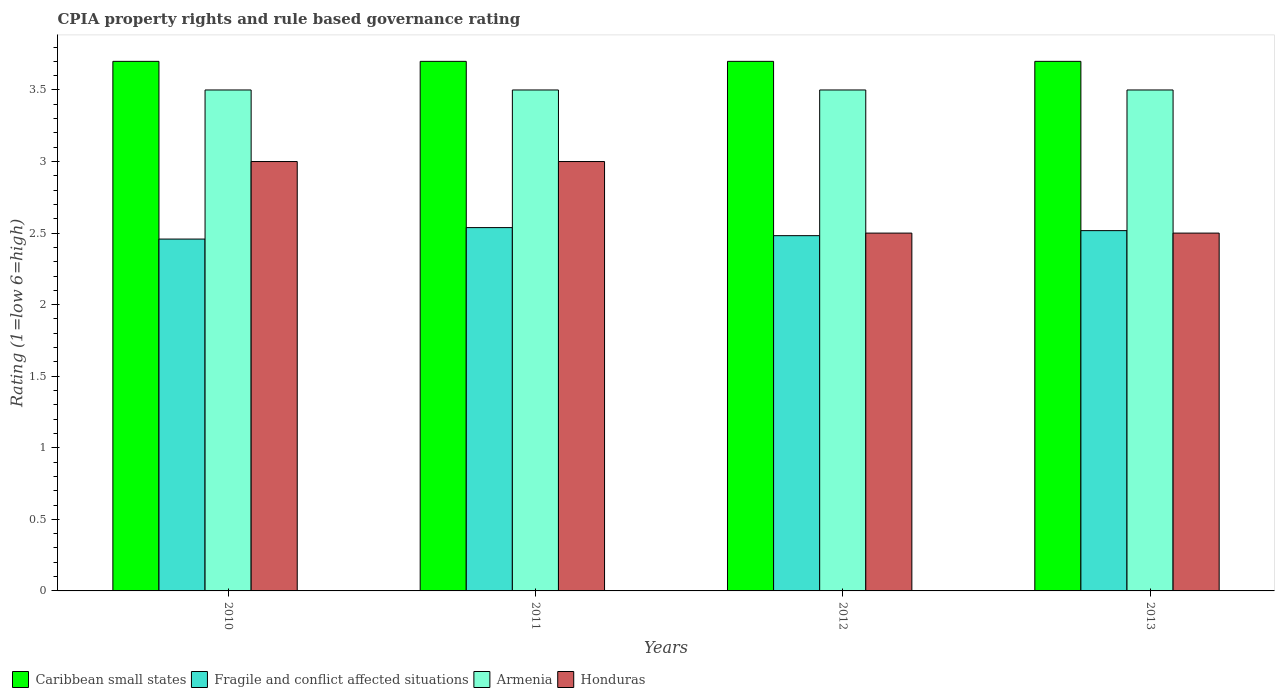How many different coloured bars are there?
Give a very brief answer. 4. How many groups of bars are there?
Provide a succinct answer. 4. Are the number of bars per tick equal to the number of legend labels?
Provide a succinct answer. Yes. Are the number of bars on each tick of the X-axis equal?
Provide a short and direct response. Yes. How many bars are there on the 2nd tick from the left?
Your answer should be compact. 4. What is the label of the 4th group of bars from the left?
Your answer should be very brief. 2013. What is the CPIA rating in Fragile and conflict affected situations in 2013?
Keep it short and to the point. 2.52. Across all years, what is the maximum CPIA rating in Caribbean small states?
Keep it short and to the point. 3.7. Across all years, what is the minimum CPIA rating in Fragile and conflict affected situations?
Make the answer very short. 2.46. What is the total CPIA rating in Fragile and conflict affected situations in the graph?
Offer a terse response. 10. What is the difference between the CPIA rating in Caribbean small states in 2010 and that in 2012?
Keep it short and to the point. 0. What is the difference between the CPIA rating in Fragile and conflict affected situations in 2011 and the CPIA rating in Honduras in 2013?
Your answer should be compact. 0.04. What is the average CPIA rating in Armenia per year?
Offer a terse response. 3.5. In the year 2011, what is the difference between the CPIA rating in Caribbean small states and CPIA rating in Armenia?
Ensure brevity in your answer.  0.2. In how many years, is the CPIA rating in Honduras greater than 3.3?
Offer a very short reply. 0. What is the ratio of the CPIA rating in Fragile and conflict affected situations in 2012 to that in 2013?
Your response must be concise. 0.99. Is the CPIA rating in Fragile and conflict affected situations in 2012 less than that in 2013?
Your response must be concise. Yes. Is the difference between the CPIA rating in Caribbean small states in 2011 and 2012 greater than the difference between the CPIA rating in Armenia in 2011 and 2012?
Your answer should be compact. No. What is the difference between the highest and the second highest CPIA rating in Caribbean small states?
Your answer should be very brief. 0. What is the difference between the highest and the lowest CPIA rating in Caribbean small states?
Keep it short and to the point. 0. Is the sum of the CPIA rating in Caribbean small states in 2011 and 2012 greater than the maximum CPIA rating in Armenia across all years?
Provide a short and direct response. Yes. What does the 3rd bar from the left in 2013 represents?
Give a very brief answer. Armenia. What does the 2nd bar from the right in 2012 represents?
Provide a short and direct response. Armenia. How many bars are there?
Provide a succinct answer. 16. Are all the bars in the graph horizontal?
Offer a very short reply. No. How many years are there in the graph?
Provide a succinct answer. 4. Are the values on the major ticks of Y-axis written in scientific E-notation?
Your answer should be very brief. No. Does the graph contain any zero values?
Provide a succinct answer. No. Does the graph contain grids?
Offer a terse response. No. How many legend labels are there?
Ensure brevity in your answer.  4. What is the title of the graph?
Give a very brief answer. CPIA property rights and rule based governance rating. Does "Tajikistan" appear as one of the legend labels in the graph?
Provide a succinct answer. No. What is the Rating (1=low 6=high) in Fragile and conflict affected situations in 2010?
Provide a succinct answer. 2.46. What is the Rating (1=low 6=high) of Armenia in 2010?
Your answer should be very brief. 3.5. What is the Rating (1=low 6=high) in Honduras in 2010?
Ensure brevity in your answer.  3. What is the Rating (1=low 6=high) in Fragile and conflict affected situations in 2011?
Your response must be concise. 2.54. What is the Rating (1=low 6=high) in Armenia in 2011?
Your answer should be very brief. 3.5. What is the Rating (1=low 6=high) in Honduras in 2011?
Keep it short and to the point. 3. What is the Rating (1=low 6=high) of Caribbean small states in 2012?
Make the answer very short. 3.7. What is the Rating (1=low 6=high) of Fragile and conflict affected situations in 2012?
Your response must be concise. 2.48. What is the Rating (1=low 6=high) in Caribbean small states in 2013?
Give a very brief answer. 3.7. What is the Rating (1=low 6=high) of Fragile and conflict affected situations in 2013?
Ensure brevity in your answer.  2.52. What is the Rating (1=low 6=high) in Armenia in 2013?
Offer a terse response. 3.5. What is the Rating (1=low 6=high) in Honduras in 2013?
Provide a succinct answer. 2.5. Across all years, what is the maximum Rating (1=low 6=high) of Fragile and conflict affected situations?
Offer a very short reply. 2.54. Across all years, what is the maximum Rating (1=low 6=high) of Honduras?
Your answer should be very brief. 3. Across all years, what is the minimum Rating (1=low 6=high) in Fragile and conflict affected situations?
Offer a very short reply. 2.46. What is the total Rating (1=low 6=high) of Fragile and conflict affected situations in the graph?
Your answer should be compact. 10. What is the total Rating (1=low 6=high) of Armenia in the graph?
Give a very brief answer. 14. What is the difference between the Rating (1=low 6=high) of Caribbean small states in 2010 and that in 2011?
Your response must be concise. 0. What is the difference between the Rating (1=low 6=high) of Fragile and conflict affected situations in 2010 and that in 2011?
Make the answer very short. -0.08. What is the difference between the Rating (1=low 6=high) in Caribbean small states in 2010 and that in 2012?
Your answer should be very brief. 0. What is the difference between the Rating (1=low 6=high) of Fragile and conflict affected situations in 2010 and that in 2012?
Your answer should be compact. -0.02. What is the difference between the Rating (1=low 6=high) of Honduras in 2010 and that in 2012?
Your answer should be very brief. 0.5. What is the difference between the Rating (1=low 6=high) in Fragile and conflict affected situations in 2010 and that in 2013?
Give a very brief answer. -0.06. What is the difference between the Rating (1=low 6=high) of Armenia in 2010 and that in 2013?
Provide a succinct answer. 0. What is the difference between the Rating (1=low 6=high) of Caribbean small states in 2011 and that in 2012?
Your response must be concise. 0. What is the difference between the Rating (1=low 6=high) of Fragile and conflict affected situations in 2011 and that in 2012?
Offer a very short reply. 0.06. What is the difference between the Rating (1=low 6=high) of Fragile and conflict affected situations in 2011 and that in 2013?
Your response must be concise. 0.02. What is the difference between the Rating (1=low 6=high) of Armenia in 2011 and that in 2013?
Make the answer very short. 0. What is the difference between the Rating (1=low 6=high) in Honduras in 2011 and that in 2013?
Make the answer very short. 0.5. What is the difference between the Rating (1=low 6=high) of Caribbean small states in 2012 and that in 2013?
Your answer should be very brief. 0. What is the difference between the Rating (1=low 6=high) in Fragile and conflict affected situations in 2012 and that in 2013?
Provide a short and direct response. -0.04. What is the difference between the Rating (1=low 6=high) in Caribbean small states in 2010 and the Rating (1=low 6=high) in Fragile and conflict affected situations in 2011?
Offer a terse response. 1.16. What is the difference between the Rating (1=low 6=high) in Fragile and conflict affected situations in 2010 and the Rating (1=low 6=high) in Armenia in 2011?
Ensure brevity in your answer.  -1.04. What is the difference between the Rating (1=low 6=high) of Fragile and conflict affected situations in 2010 and the Rating (1=low 6=high) of Honduras in 2011?
Ensure brevity in your answer.  -0.54. What is the difference between the Rating (1=low 6=high) of Armenia in 2010 and the Rating (1=low 6=high) of Honduras in 2011?
Offer a very short reply. 0.5. What is the difference between the Rating (1=low 6=high) of Caribbean small states in 2010 and the Rating (1=low 6=high) of Fragile and conflict affected situations in 2012?
Ensure brevity in your answer.  1.22. What is the difference between the Rating (1=low 6=high) in Caribbean small states in 2010 and the Rating (1=low 6=high) in Armenia in 2012?
Offer a very short reply. 0.2. What is the difference between the Rating (1=low 6=high) of Caribbean small states in 2010 and the Rating (1=low 6=high) of Honduras in 2012?
Make the answer very short. 1.2. What is the difference between the Rating (1=low 6=high) in Fragile and conflict affected situations in 2010 and the Rating (1=low 6=high) in Armenia in 2012?
Your answer should be compact. -1.04. What is the difference between the Rating (1=low 6=high) of Fragile and conflict affected situations in 2010 and the Rating (1=low 6=high) of Honduras in 2012?
Provide a short and direct response. -0.04. What is the difference between the Rating (1=low 6=high) of Armenia in 2010 and the Rating (1=low 6=high) of Honduras in 2012?
Provide a succinct answer. 1. What is the difference between the Rating (1=low 6=high) of Caribbean small states in 2010 and the Rating (1=low 6=high) of Fragile and conflict affected situations in 2013?
Make the answer very short. 1.18. What is the difference between the Rating (1=low 6=high) in Fragile and conflict affected situations in 2010 and the Rating (1=low 6=high) in Armenia in 2013?
Offer a terse response. -1.04. What is the difference between the Rating (1=low 6=high) of Fragile and conflict affected situations in 2010 and the Rating (1=low 6=high) of Honduras in 2013?
Your answer should be compact. -0.04. What is the difference between the Rating (1=low 6=high) in Armenia in 2010 and the Rating (1=low 6=high) in Honduras in 2013?
Offer a terse response. 1. What is the difference between the Rating (1=low 6=high) in Caribbean small states in 2011 and the Rating (1=low 6=high) in Fragile and conflict affected situations in 2012?
Your response must be concise. 1.22. What is the difference between the Rating (1=low 6=high) in Caribbean small states in 2011 and the Rating (1=low 6=high) in Armenia in 2012?
Offer a terse response. 0.2. What is the difference between the Rating (1=low 6=high) of Fragile and conflict affected situations in 2011 and the Rating (1=low 6=high) of Armenia in 2012?
Provide a succinct answer. -0.96. What is the difference between the Rating (1=low 6=high) of Fragile and conflict affected situations in 2011 and the Rating (1=low 6=high) of Honduras in 2012?
Your response must be concise. 0.04. What is the difference between the Rating (1=low 6=high) of Caribbean small states in 2011 and the Rating (1=low 6=high) of Fragile and conflict affected situations in 2013?
Ensure brevity in your answer.  1.18. What is the difference between the Rating (1=low 6=high) in Caribbean small states in 2011 and the Rating (1=low 6=high) in Armenia in 2013?
Ensure brevity in your answer.  0.2. What is the difference between the Rating (1=low 6=high) in Fragile and conflict affected situations in 2011 and the Rating (1=low 6=high) in Armenia in 2013?
Your answer should be compact. -0.96. What is the difference between the Rating (1=low 6=high) in Fragile and conflict affected situations in 2011 and the Rating (1=low 6=high) in Honduras in 2013?
Your answer should be compact. 0.04. What is the difference between the Rating (1=low 6=high) in Caribbean small states in 2012 and the Rating (1=low 6=high) in Fragile and conflict affected situations in 2013?
Your answer should be compact. 1.18. What is the difference between the Rating (1=low 6=high) of Fragile and conflict affected situations in 2012 and the Rating (1=low 6=high) of Armenia in 2013?
Offer a terse response. -1.02. What is the difference between the Rating (1=low 6=high) in Fragile and conflict affected situations in 2012 and the Rating (1=low 6=high) in Honduras in 2013?
Offer a terse response. -0.02. What is the difference between the Rating (1=low 6=high) of Armenia in 2012 and the Rating (1=low 6=high) of Honduras in 2013?
Your response must be concise. 1. What is the average Rating (1=low 6=high) of Caribbean small states per year?
Ensure brevity in your answer.  3.7. What is the average Rating (1=low 6=high) in Fragile and conflict affected situations per year?
Keep it short and to the point. 2.5. What is the average Rating (1=low 6=high) of Armenia per year?
Keep it short and to the point. 3.5. What is the average Rating (1=low 6=high) in Honduras per year?
Your answer should be compact. 2.75. In the year 2010, what is the difference between the Rating (1=low 6=high) of Caribbean small states and Rating (1=low 6=high) of Fragile and conflict affected situations?
Make the answer very short. 1.24. In the year 2010, what is the difference between the Rating (1=low 6=high) in Caribbean small states and Rating (1=low 6=high) in Honduras?
Offer a very short reply. 0.7. In the year 2010, what is the difference between the Rating (1=low 6=high) in Fragile and conflict affected situations and Rating (1=low 6=high) in Armenia?
Offer a terse response. -1.04. In the year 2010, what is the difference between the Rating (1=low 6=high) in Fragile and conflict affected situations and Rating (1=low 6=high) in Honduras?
Offer a terse response. -0.54. In the year 2011, what is the difference between the Rating (1=low 6=high) in Caribbean small states and Rating (1=low 6=high) in Fragile and conflict affected situations?
Provide a short and direct response. 1.16. In the year 2011, what is the difference between the Rating (1=low 6=high) in Caribbean small states and Rating (1=low 6=high) in Honduras?
Make the answer very short. 0.7. In the year 2011, what is the difference between the Rating (1=low 6=high) in Fragile and conflict affected situations and Rating (1=low 6=high) in Armenia?
Make the answer very short. -0.96. In the year 2011, what is the difference between the Rating (1=low 6=high) of Fragile and conflict affected situations and Rating (1=low 6=high) of Honduras?
Provide a succinct answer. -0.46. In the year 2012, what is the difference between the Rating (1=low 6=high) in Caribbean small states and Rating (1=low 6=high) in Fragile and conflict affected situations?
Offer a very short reply. 1.22. In the year 2012, what is the difference between the Rating (1=low 6=high) of Caribbean small states and Rating (1=low 6=high) of Honduras?
Provide a short and direct response. 1.2. In the year 2012, what is the difference between the Rating (1=low 6=high) in Fragile and conflict affected situations and Rating (1=low 6=high) in Armenia?
Give a very brief answer. -1.02. In the year 2012, what is the difference between the Rating (1=low 6=high) of Fragile and conflict affected situations and Rating (1=low 6=high) of Honduras?
Make the answer very short. -0.02. In the year 2013, what is the difference between the Rating (1=low 6=high) in Caribbean small states and Rating (1=low 6=high) in Fragile and conflict affected situations?
Offer a terse response. 1.18. In the year 2013, what is the difference between the Rating (1=low 6=high) of Caribbean small states and Rating (1=low 6=high) of Honduras?
Offer a very short reply. 1.2. In the year 2013, what is the difference between the Rating (1=low 6=high) of Fragile and conflict affected situations and Rating (1=low 6=high) of Armenia?
Your answer should be compact. -0.98. In the year 2013, what is the difference between the Rating (1=low 6=high) of Fragile and conflict affected situations and Rating (1=low 6=high) of Honduras?
Your answer should be compact. 0.02. What is the ratio of the Rating (1=low 6=high) of Caribbean small states in 2010 to that in 2011?
Make the answer very short. 1. What is the ratio of the Rating (1=low 6=high) in Fragile and conflict affected situations in 2010 to that in 2011?
Offer a very short reply. 0.97. What is the ratio of the Rating (1=low 6=high) in Armenia in 2010 to that in 2011?
Your answer should be compact. 1. What is the ratio of the Rating (1=low 6=high) of Honduras in 2010 to that in 2011?
Provide a short and direct response. 1. What is the ratio of the Rating (1=low 6=high) in Fragile and conflict affected situations in 2010 to that in 2012?
Provide a succinct answer. 0.99. What is the ratio of the Rating (1=low 6=high) in Armenia in 2010 to that in 2012?
Your answer should be very brief. 1. What is the ratio of the Rating (1=low 6=high) of Honduras in 2010 to that in 2012?
Keep it short and to the point. 1.2. What is the ratio of the Rating (1=low 6=high) of Caribbean small states in 2010 to that in 2013?
Offer a very short reply. 1. What is the ratio of the Rating (1=low 6=high) of Fragile and conflict affected situations in 2010 to that in 2013?
Your response must be concise. 0.98. What is the ratio of the Rating (1=low 6=high) of Honduras in 2010 to that in 2013?
Provide a short and direct response. 1.2. What is the ratio of the Rating (1=low 6=high) of Fragile and conflict affected situations in 2011 to that in 2012?
Your answer should be compact. 1.02. What is the ratio of the Rating (1=low 6=high) of Armenia in 2011 to that in 2012?
Give a very brief answer. 1. What is the ratio of the Rating (1=low 6=high) of Honduras in 2011 to that in 2012?
Your answer should be compact. 1.2. What is the ratio of the Rating (1=low 6=high) in Caribbean small states in 2011 to that in 2013?
Your response must be concise. 1. What is the ratio of the Rating (1=low 6=high) of Fragile and conflict affected situations in 2011 to that in 2013?
Your response must be concise. 1.01. What is the ratio of the Rating (1=low 6=high) of Fragile and conflict affected situations in 2012 to that in 2013?
Your response must be concise. 0.99. What is the ratio of the Rating (1=low 6=high) in Armenia in 2012 to that in 2013?
Give a very brief answer. 1. What is the ratio of the Rating (1=low 6=high) of Honduras in 2012 to that in 2013?
Provide a succinct answer. 1. What is the difference between the highest and the second highest Rating (1=low 6=high) of Caribbean small states?
Make the answer very short. 0. What is the difference between the highest and the second highest Rating (1=low 6=high) in Fragile and conflict affected situations?
Offer a very short reply. 0.02. What is the difference between the highest and the second highest Rating (1=low 6=high) of Armenia?
Your answer should be very brief. 0. What is the difference between the highest and the second highest Rating (1=low 6=high) of Honduras?
Provide a short and direct response. 0. What is the difference between the highest and the lowest Rating (1=low 6=high) of Caribbean small states?
Provide a succinct answer. 0. What is the difference between the highest and the lowest Rating (1=low 6=high) of Fragile and conflict affected situations?
Keep it short and to the point. 0.08. What is the difference between the highest and the lowest Rating (1=low 6=high) in Armenia?
Make the answer very short. 0. 